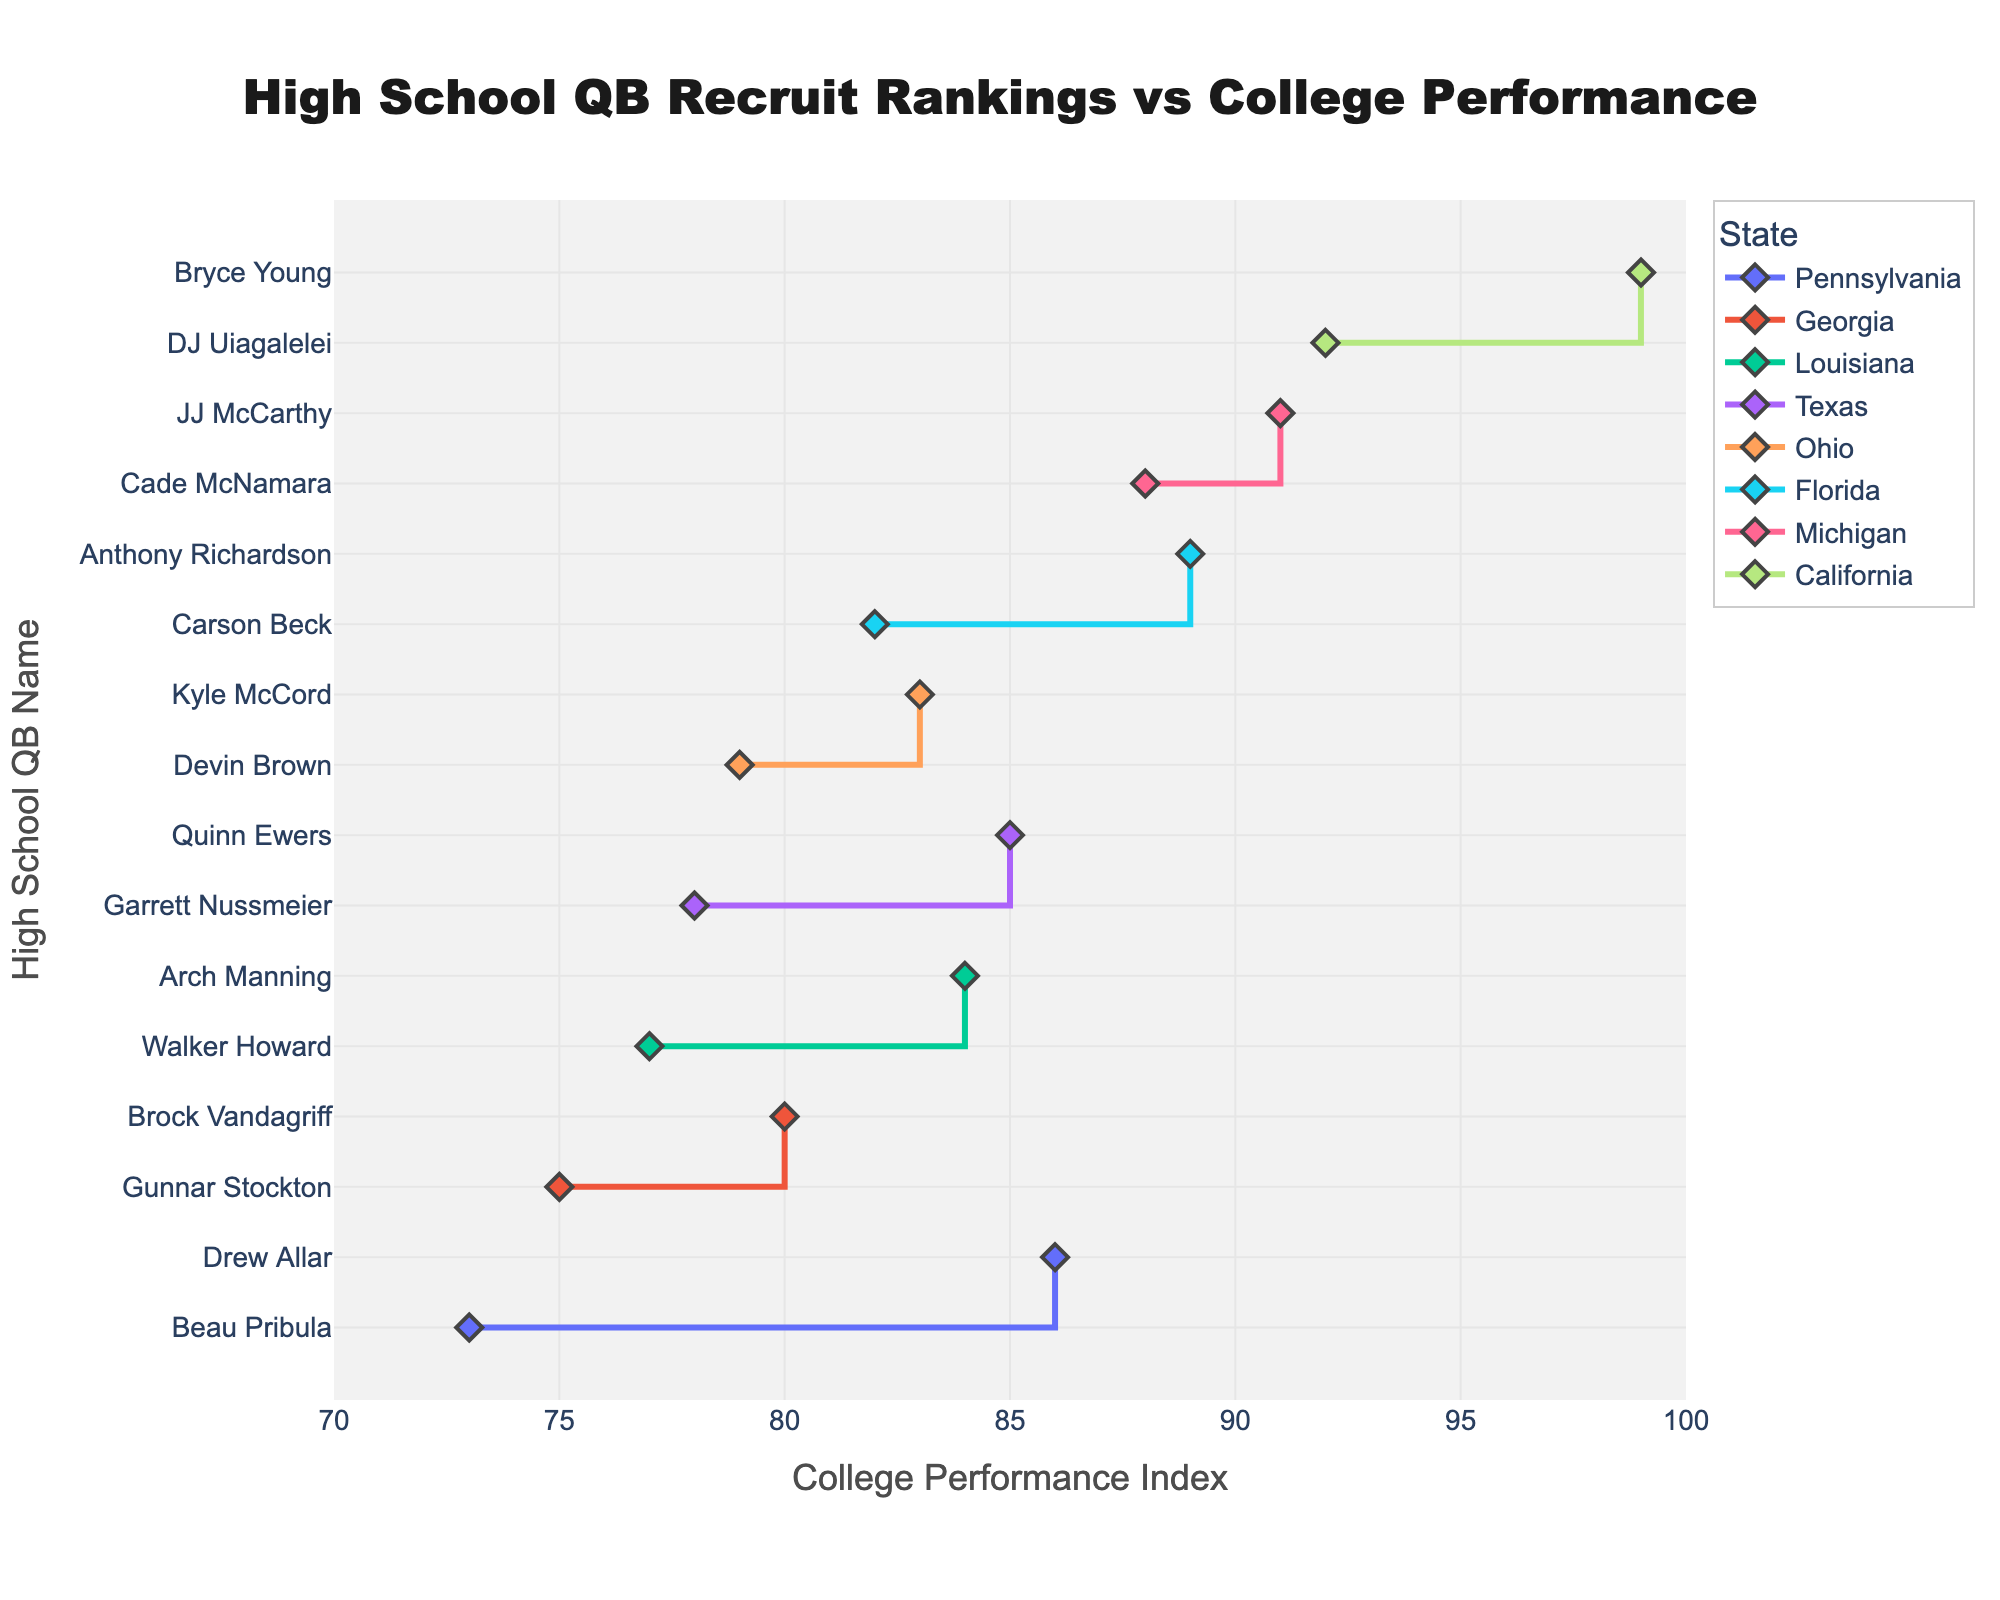What is the title of the plot? The title is placed prominently at the top of the plot. It reads "High School QB Recruit Rankings vs College Performance".
Answer: High School QB Recruit Rankings vs College Performance What does the x-axis represent? The x-axis represents the "College Performance Index," a numerical measure of the players' performance in college. The axis title and tick labels confirm this.
Answer: College Performance Index Which high school QB from Florida has the highest college performance index? The plot highlights markers for each QB with their respective college performance index. Bryce Young stands out as the high school QB from Florida with the highest performance index, visible at the highest position in the Florida group.
Answer: Carson Beck Which state has the most high-performing QBs in college? By observing the number of markers and their positions on the x-axis across states, California hosts several QBs with high-performance indices.
Answer: California What is the range of college performance indices shown on the x-axis? The x-axis starts at 70 and ends at 100, as marked by the tick labels on the axis grid.
Answer: 70 to 100 How does the college performance of the highest-ranked QB in Texas compare to the highest-ranked QB in California? Compare the positions of the markers for the top-ranked QBs in Texas and California. The marker for Bryce Young (California) at 99 surpasses the marker for Quinn Ewers (Texas) at 85.
Answer: Bryce Young has a higher performance index Do high school QB rankings correlate with college performance in the states shown? Evaluate the spread and relative positions of the markers on the x-axis. While some high school top performers excel in college, others do not, indicating no clear, consistent trend.
Answer: No clear correlation What is the average college performance index of the highest-ranked QBs? List all highest-ranked QBs from each state, sum their performance indices, and divide by the number of states. The calculations show 92 (DJ Uiagalelei) + 85 (Quinn Ewers) + 89 (Anthony Richardson) + 80 (Brock Vandagriff) + 83 (Kyle McCord) + 77 (Walker Howard) + 86 (Drew Allar) + 88 (Cade McNamara) = 680. Divide by 8 states gives an average of 85.
Answer: 85 How many QBs from Michigan are represented in the plot? Count the markers or lines associated with Michigan on the y-axis. There are two diamond-shaped markers under Michigan.
Answer: Two Who has a higher college performance index, JJ McCarthy or Gunnar Stockton? Look at the markers for JJ McCarthy and Gunnar Stockton on the x-axis. JJ McCarthy's marker is at 91, while Gunnar Stockton's is at 75.
Answer: JJ McCarthy Which QB from Pennsylvania has the lowest college performance index? Compare the markers for QBs from Pennsylvania. Beau Pribula's marker is at 73, lower than Drew Allar’s 86.
Answer: Beau Pribula 